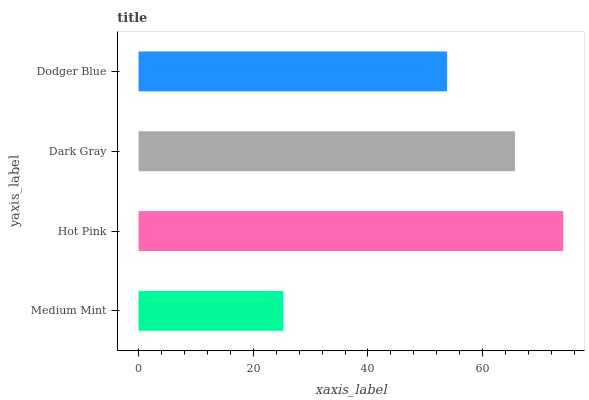Is Medium Mint the minimum?
Answer yes or no. Yes. Is Hot Pink the maximum?
Answer yes or no. Yes. Is Dark Gray the minimum?
Answer yes or no. No. Is Dark Gray the maximum?
Answer yes or no. No. Is Hot Pink greater than Dark Gray?
Answer yes or no. Yes. Is Dark Gray less than Hot Pink?
Answer yes or no. Yes. Is Dark Gray greater than Hot Pink?
Answer yes or no. No. Is Hot Pink less than Dark Gray?
Answer yes or no. No. Is Dark Gray the high median?
Answer yes or no. Yes. Is Dodger Blue the low median?
Answer yes or no. Yes. Is Medium Mint the high median?
Answer yes or no. No. Is Hot Pink the low median?
Answer yes or no. No. 